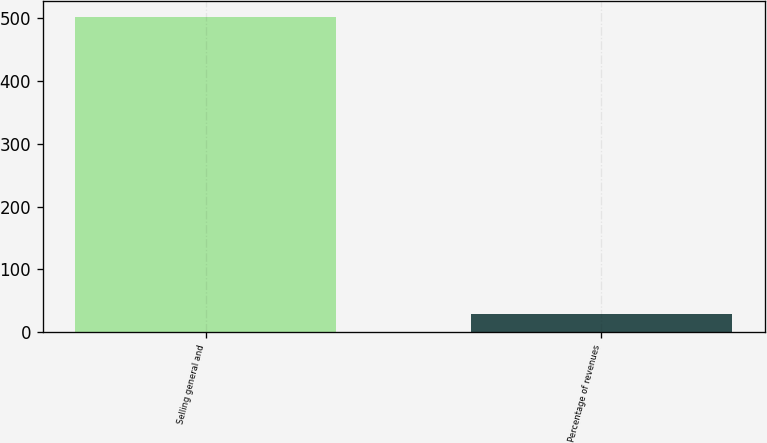<chart> <loc_0><loc_0><loc_500><loc_500><bar_chart><fcel>Selling general and<fcel>Percentage of revenues<nl><fcel>502.2<fcel>29.6<nl></chart> 